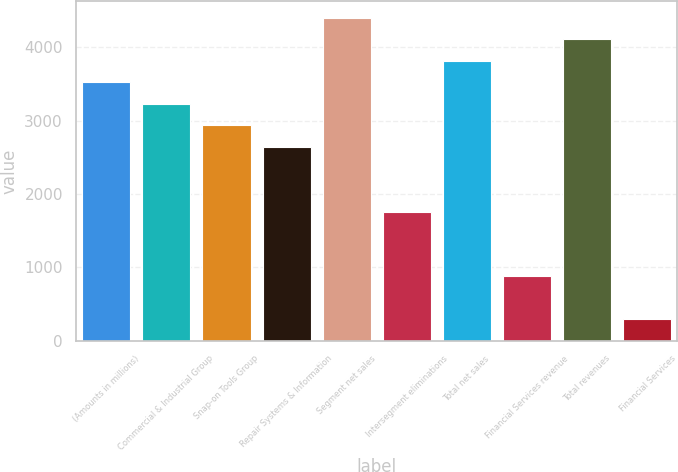Convert chart to OTSL. <chart><loc_0><loc_0><loc_500><loc_500><bar_chart><fcel>(Amounts in millions)<fcel>Commercial & Industrial Group<fcel>Snap-on Tools Group<fcel>Repair Systems & Information<fcel>Segment net sales<fcel>Intersegment eliminations<fcel>Total net sales<fcel>Financial Services revenue<fcel>Total revenues<fcel>Financial Services<nl><fcel>3522.2<fcel>3228.75<fcel>2935.3<fcel>2641.85<fcel>4402.55<fcel>1761.5<fcel>3815.65<fcel>881.15<fcel>4109.1<fcel>294.25<nl></chart> 